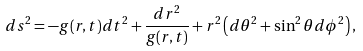<formula> <loc_0><loc_0><loc_500><loc_500>d s ^ { 2 } = - g ( r , t ) d t ^ { 2 } + \frac { d r ^ { 2 } } { g ( r , t ) } + r ^ { 2 } \left ( d \theta ^ { 2 } + \sin ^ { 2 } \theta d \phi ^ { 2 } \right ) ,</formula> 